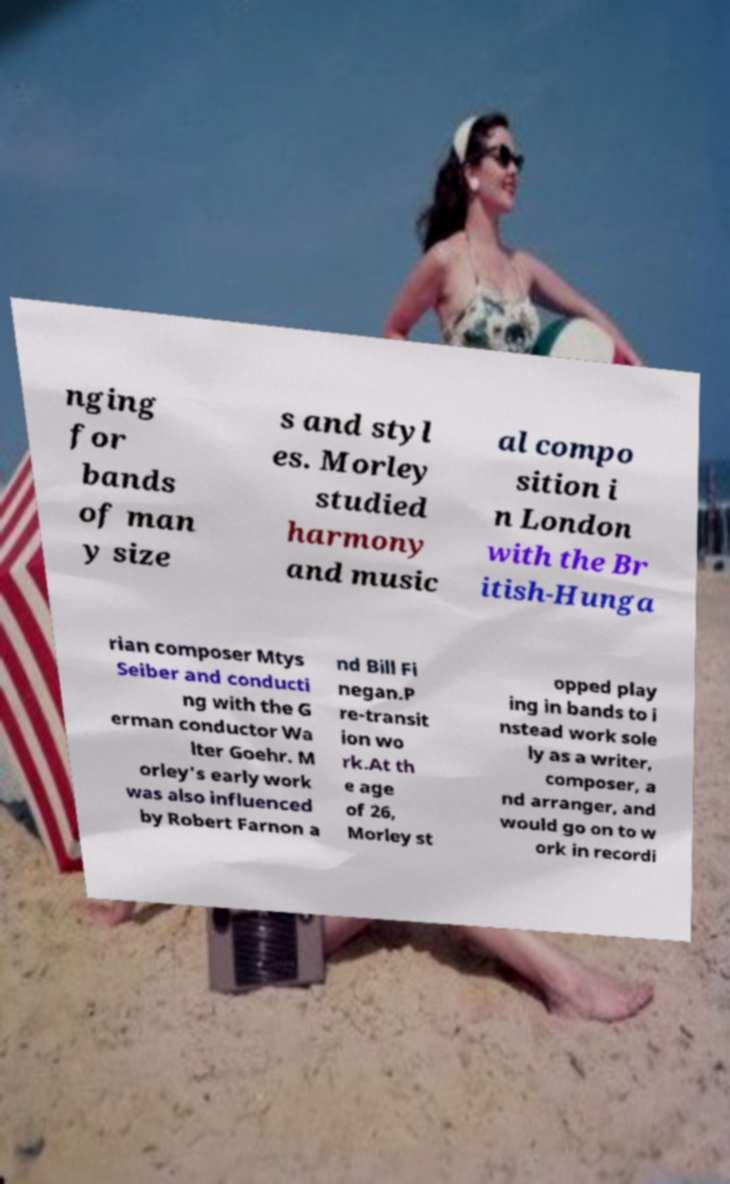I need the written content from this picture converted into text. Can you do that? nging for bands of man y size s and styl es. Morley studied harmony and music al compo sition i n London with the Br itish-Hunga rian composer Mtys Seiber and conducti ng with the G erman conductor Wa lter Goehr. M orley's early work was also influenced by Robert Farnon a nd Bill Fi negan.P re-transit ion wo rk.At th e age of 26, Morley st opped play ing in bands to i nstead work sole ly as a writer, composer, a nd arranger, and would go on to w ork in recordi 